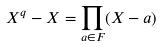<formula> <loc_0><loc_0><loc_500><loc_500>X ^ { q } - X = \prod _ { a \in F } ( X - a )</formula> 